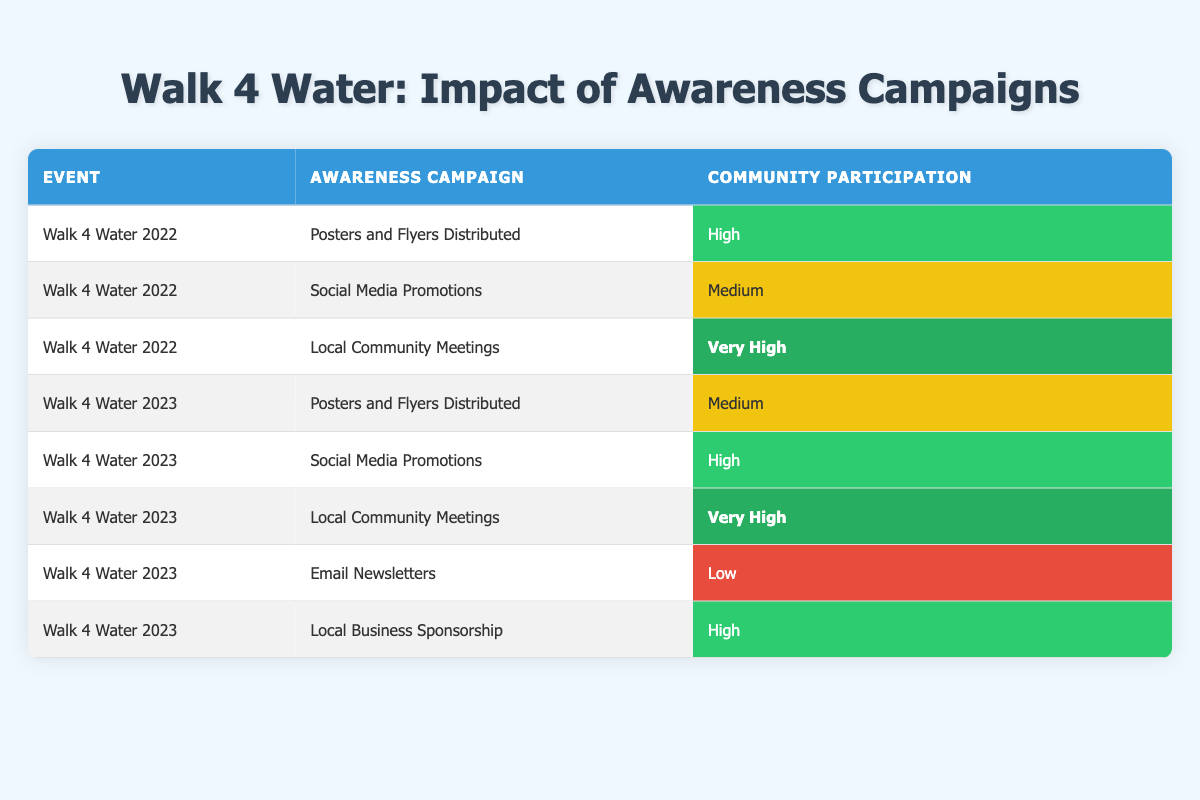What was the community participation rating for the "Walk 4 Water 2022" event with "Local Community Meetings"? In the table, the row for "Walk 4 Water 2022" under "Local Community Meetings" indicates that the community participation was rated as "Very High".
Answer: Very High Which awareness campaign had the lowest community participation in "Walk 4 Water 2023"? Looking at the table for "Walk 4 Water 2023", the row for "Email Newsletters" shows a participation rating of "Low", which is the lowest compared to the others.
Answer: Low Did community participation improve from "Walk 4 Water 2022" to "Walk 4 Water 2023" for "Social Media Promotions"? In "Walk 4 Water 2022", the participation for "Social Media Promotions" was rated "Medium", while in "Walk 4 Water 2023", it was "High". Since "High" is an improvement over "Medium", the answer is yes.
Answer: Yes What is the percentage increase in community participation for "Local Community Meetings" from 2022 to 2023? In 2022, the participation was "Very High", while in 2023 it remained "Very High". Since there is no change in the rating, there is a 0% increase. To quantify this, it's "Very High" to "Very High", no difference in percentage.
Answer: 0% For "Walk 4 Water 2023," how many campaigns had high or very high community participation? Analyzing the rows for "Walk 4 Water 2023", both "Local Community Meetings" and "Social Media Promotions" are rated as "Very High" and "High" respectively, totaling 3 campaigns, which is "Local Community Meetings" (Very High), "Social Media Promotions" (High), and "Local Business Sponsorship" (High).
Answer: 3 How many awareness campaigns resulted in medium community participation for the events combined? In the table, "Walk 4 Water 2022" has one campaign ("Social Media Promotions") rated medium, and "Walk 4 Water 2023" has one campaign ("Posters and Flyers Distributed") rated medium, making a total of 2 campaigns.
Answer: 2 